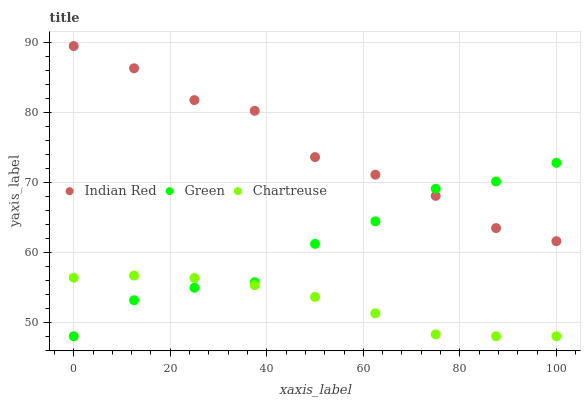Does Chartreuse have the minimum area under the curve?
Answer yes or no. Yes. Does Indian Red have the maximum area under the curve?
Answer yes or no. Yes. Does Green have the minimum area under the curve?
Answer yes or no. No. Does Green have the maximum area under the curve?
Answer yes or no. No. Is Chartreuse the smoothest?
Answer yes or no. Yes. Is Indian Red the roughest?
Answer yes or no. Yes. Is Green the smoothest?
Answer yes or no. No. Is Green the roughest?
Answer yes or no. No. Does Chartreuse have the lowest value?
Answer yes or no. Yes. Does Indian Red have the lowest value?
Answer yes or no. No. Does Indian Red have the highest value?
Answer yes or no. Yes. Does Green have the highest value?
Answer yes or no. No. Is Chartreuse less than Indian Red?
Answer yes or no. Yes. Is Indian Red greater than Chartreuse?
Answer yes or no. Yes. Does Green intersect Chartreuse?
Answer yes or no. Yes. Is Green less than Chartreuse?
Answer yes or no. No. Is Green greater than Chartreuse?
Answer yes or no. No. Does Chartreuse intersect Indian Red?
Answer yes or no. No. 